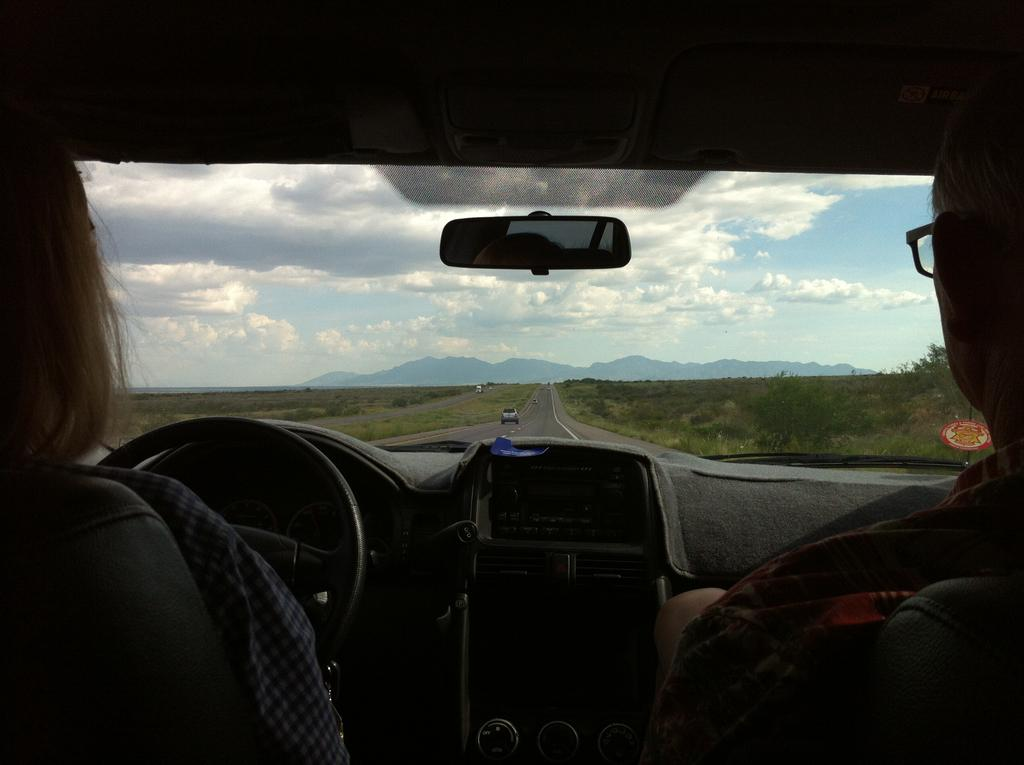How many people are inside the car in the image? There are two persons sitting inside the car. What object can be seen in the image that is typically used for self-reflection or checking one's appearance? There is a mirror in the image. What can be seen in the background of the image? The sky is visible in the image. What type of music is being played by the root in the image? There is no root or music present in the image. 